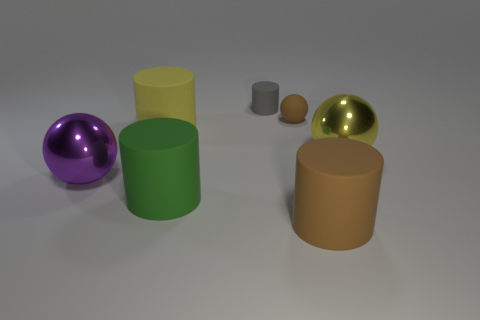Subtract all purple balls. How many balls are left? 2 Add 2 purple metal balls. How many objects exist? 9 Subtract 1 spheres. How many spheres are left? 2 Subtract all brown spheres. How many spheres are left? 2 Subtract all cylinders. How many objects are left? 3 Subtract all big purple balls. Subtract all brown spheres. How many objects are left? 5 Add 3 big yellow matte things. How many big yellow matte things are left? 4 Add 1 small brown rubber spheres. How many small brown rubber spheres exist? 2 Subtract 1 yellow cylinders. How many objects are left? 6 Subtract all cyan balls. Subtract all blue cubes. How many balls are left? 3 